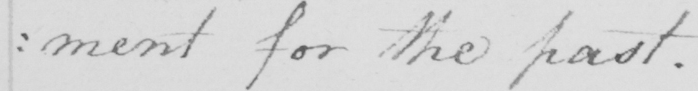Can you tell me what this handwritten text says? : ment for the past . 